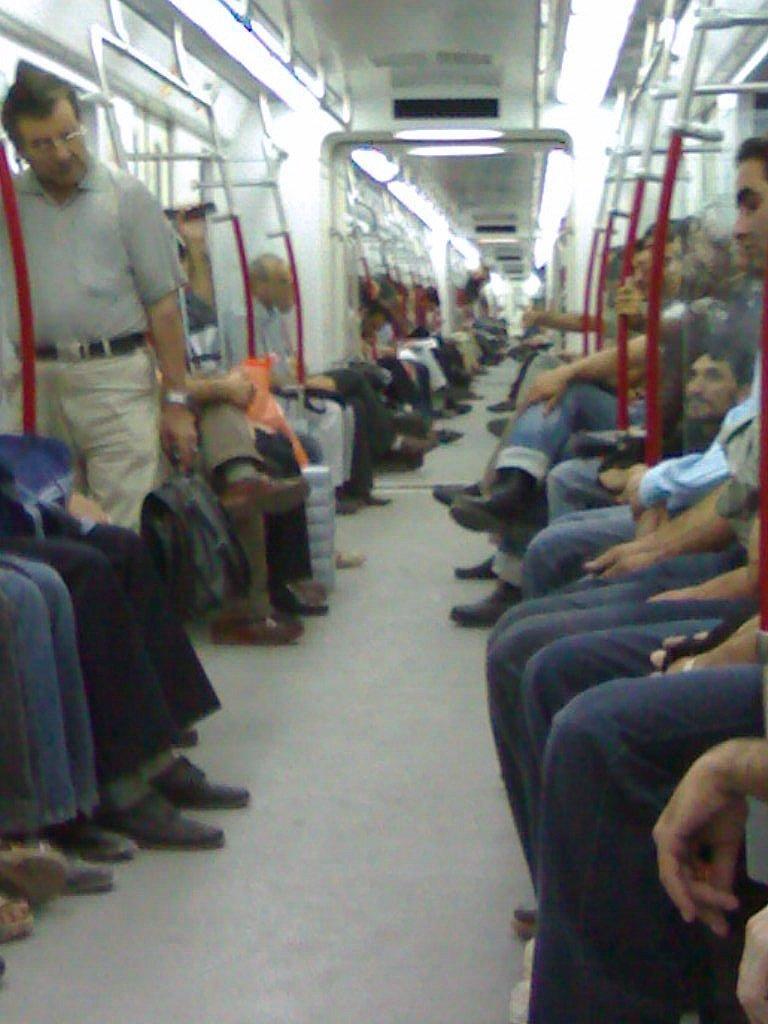Could you give a brief overview of what you see in this image? This picture shows an inner view of a train and we see man standing and holding a bag in his hand and he wore spectacles on his face and we see people seated. 